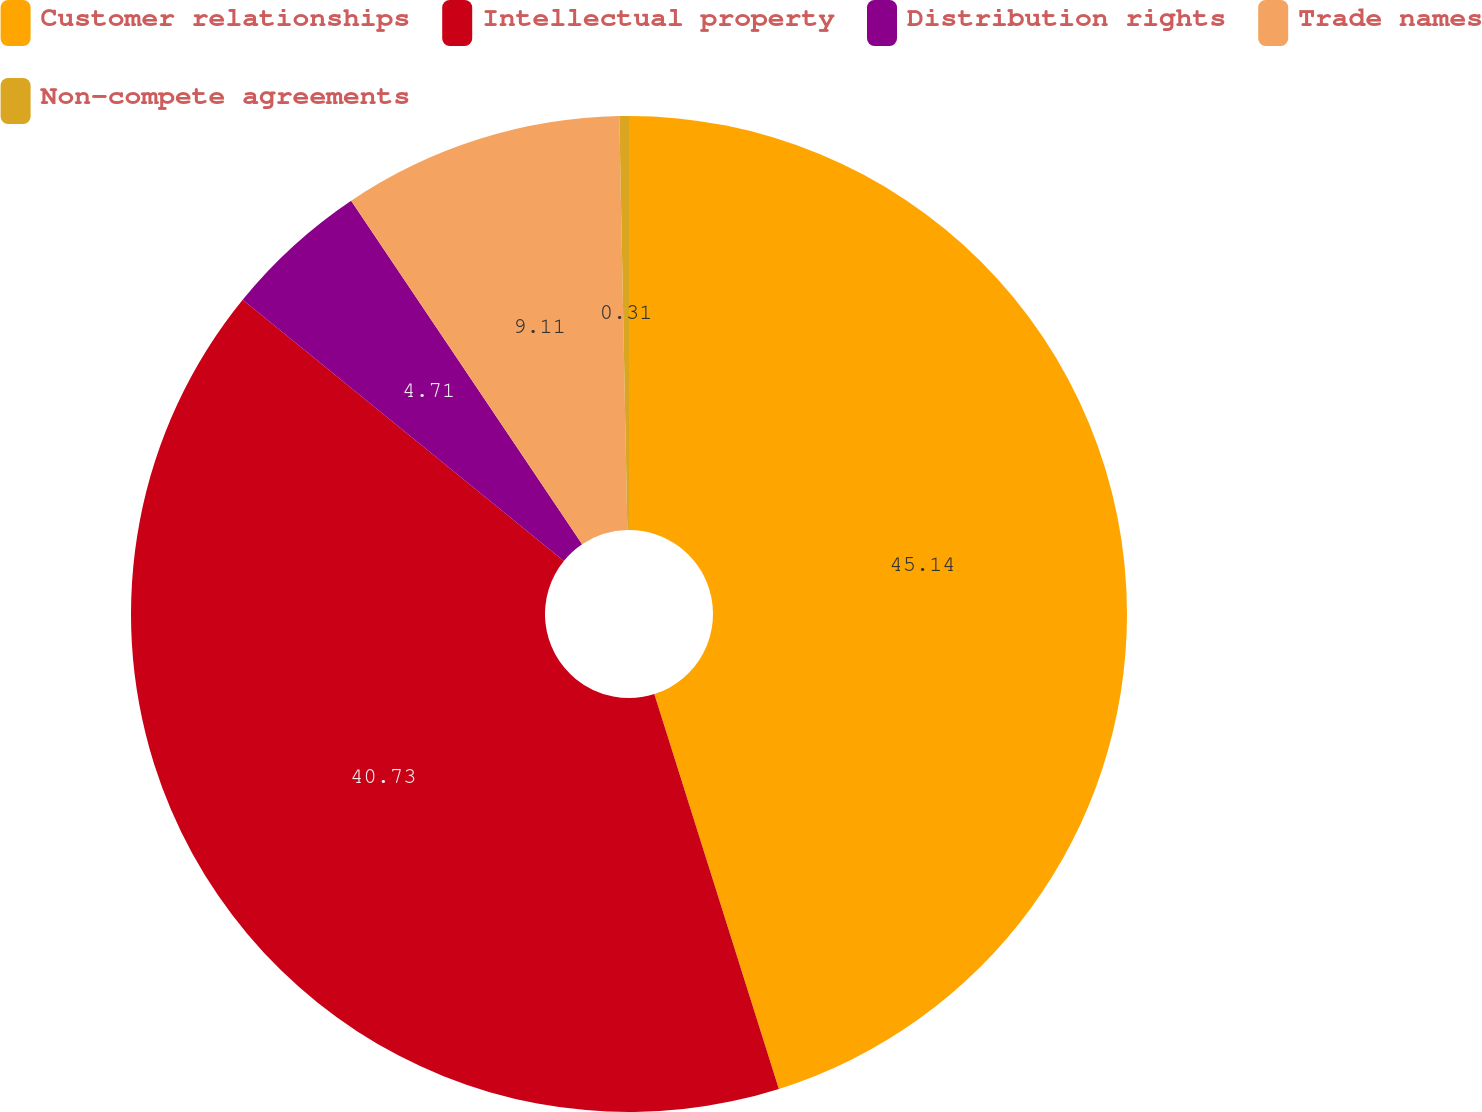Convert chart to OTSL. <chart><loc_0><loc_0><loc_500><loc_500><pie_chart><fcel>Customer relationships<fcel>Intellectual property<fcel>Distribution rights<fcel>Trade names<fcel>Non-compete agreements<nl><fcel>45.13%<fcel>40.73%<fcel>4.71%<fcel>9.11%<fcel>0.31%<nl></chart> 